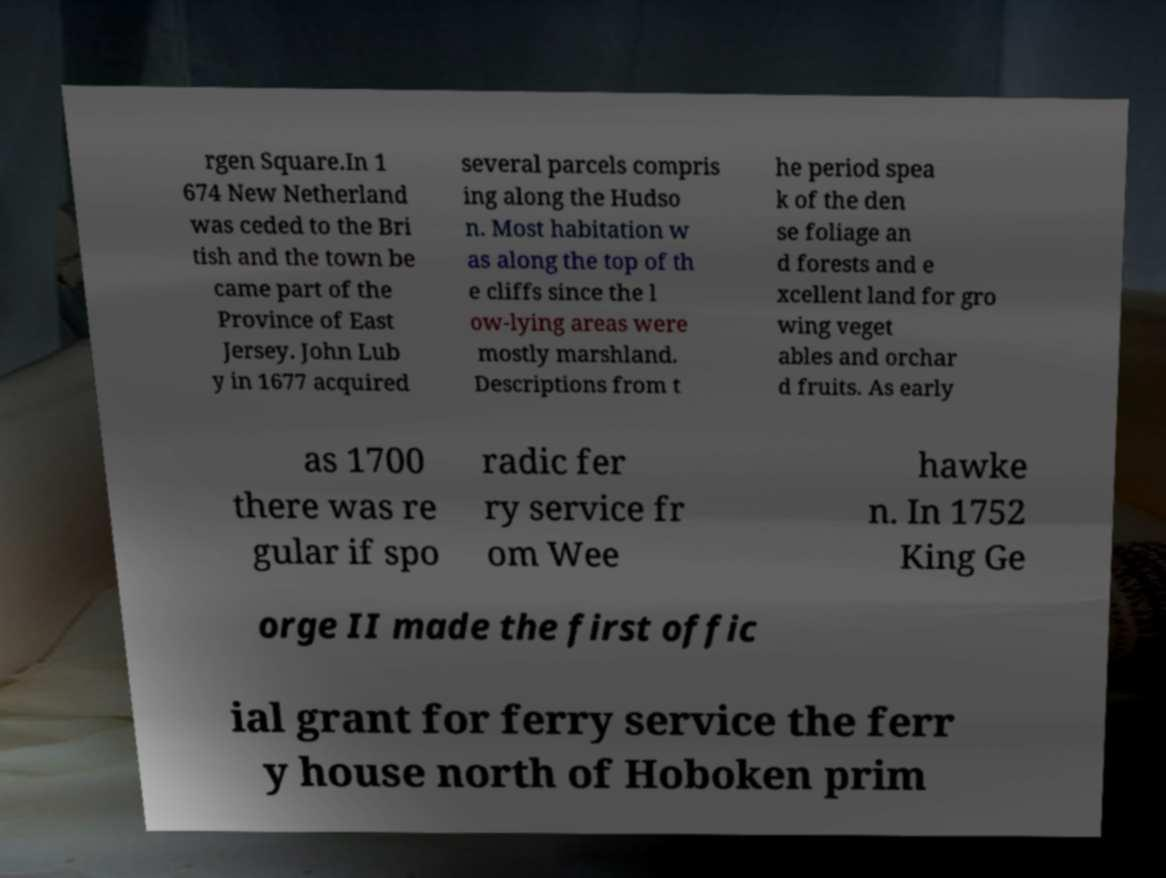There's text embedded in this image that I need extracted. Can you transcribe it verbatim? rgen Square.In 1 674 New Netherland was ceded to the Bri tish and the town be came part of the Province of East Jersey. John Lub y in 1677 acquired several parcels compris ing along the Hudso n. Most habitation w as along the top of th e cliffs since the l ow-lying areas were mostly marshland. Descriptions from t he period spea k of the den se foliage an d forests and e xcellent land for gro wing veget ables and orchar d fruits. As early as 1700 there was re gular if spo radic fer ry service fr om Wee hawke n. In 1752 King Ge orge II made the first offic ial grant for ferry service the ferr y house north of Hoboken prim 